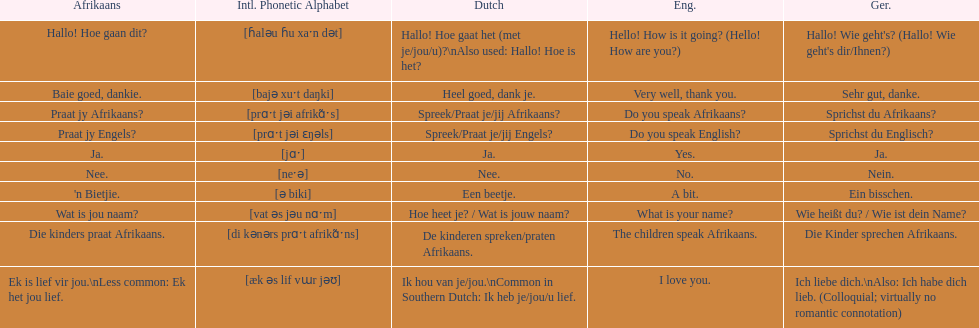How can i express 'i love you' in the afrikaans language? Ek is lief vir jou. 